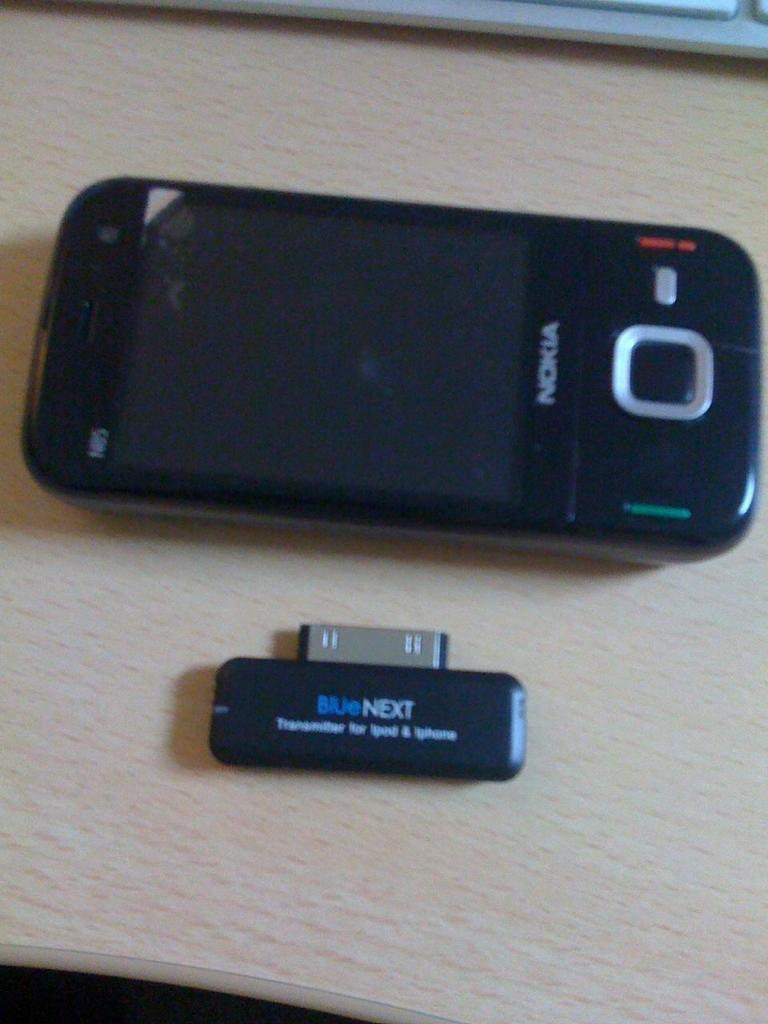What electronic device is visible in the image? There is a mobile phone in the image. What other object related to technology can be seen in the image? There is a keyboard and a pen drive in the image. Where are these objects located? All these objects are on a table. Can you describe the lighting in the image? The bottom left corner of the image appears to be dark. What type of plant is growing on the chin of the person in the image? There is no person or plant visible in the image. What type of pleasure can be derived from the objects in the image? The image does not convey any information about the pleasure derived from the objects; it only shows a mobile phone, keyboard, and pen drive on a table. 